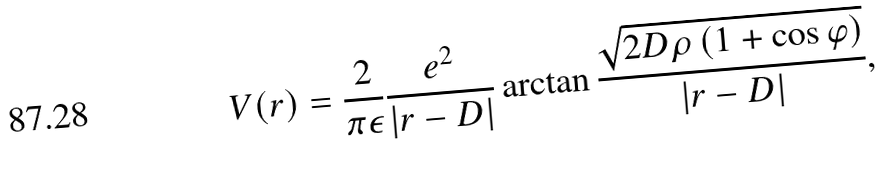Convert formula to latex. <formula><loc_0><loc_0><loc_500><loc_500>V ( r ) = \frac { 2 } { \pi \epsilon } \frac { e ^ { 2 } } { | r - D | } \arctan \frac { \sqrt { 2 D \rho \left ( 1 + \cos \varphi \right ) } } { | r - D | } ,</formula> 